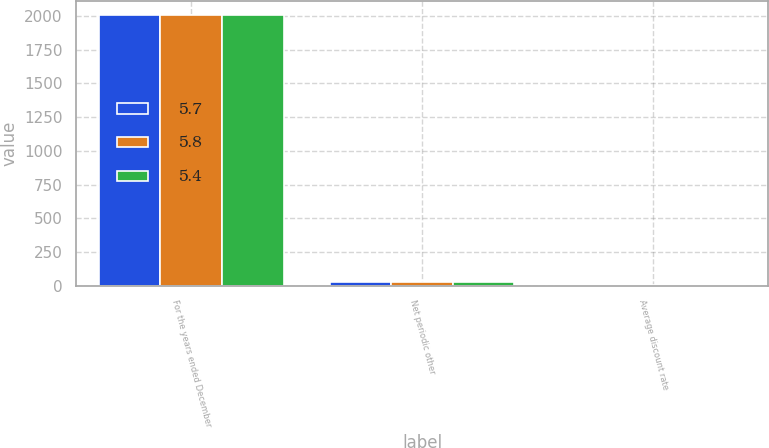Convert chart to OTSL. <chart><loc_0><loc_0><loc_500><loc_500><stacked_bar_chart><ecel><fcel>For the years ended December<fcel>Net periodic other<fcel>Average discount rate<nl><fcel>5.7<fcel>2007<fcel>24.7<fcel>5.8<nl><fcel>5.8<fcel>2006<fcel>28.7<fcel>5.4<nl><fcel>5.4<fcel>2005<fcel>24.6<fcel>5.7<nl></chart> 